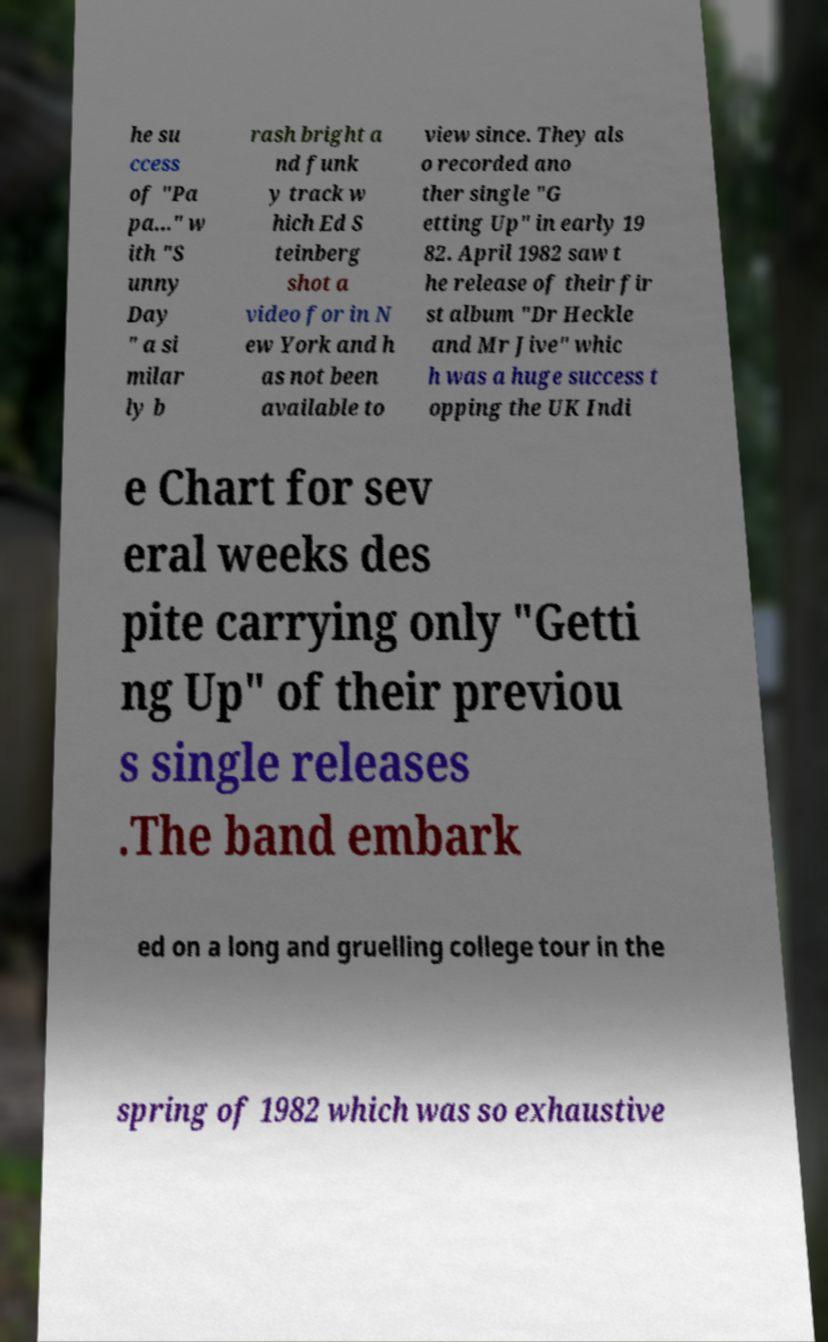There's text embedded in this image that I need extracted. Can you transcribe it verbatim? he su ccess of "Pa pa..." w ith "S unny Day " a si milar ly b rash bright a nd funk y track w hich Ed S teinberg shot a video for in N ew York and h as not been available to view since. They als o recorded ano ther single "G etting Up" in early 19 82. April 1982 saw t he release of their fir st album "Dr Heckle and Mr Jive" whic h was a huge success t opping the UK Indi e Chart for sev eral weeks des pite carrying only "Getti ng Up" of their previou s single releases .The band embark ed on a long and gruelling college tour in the spring of 1982 which was so exhaustive 